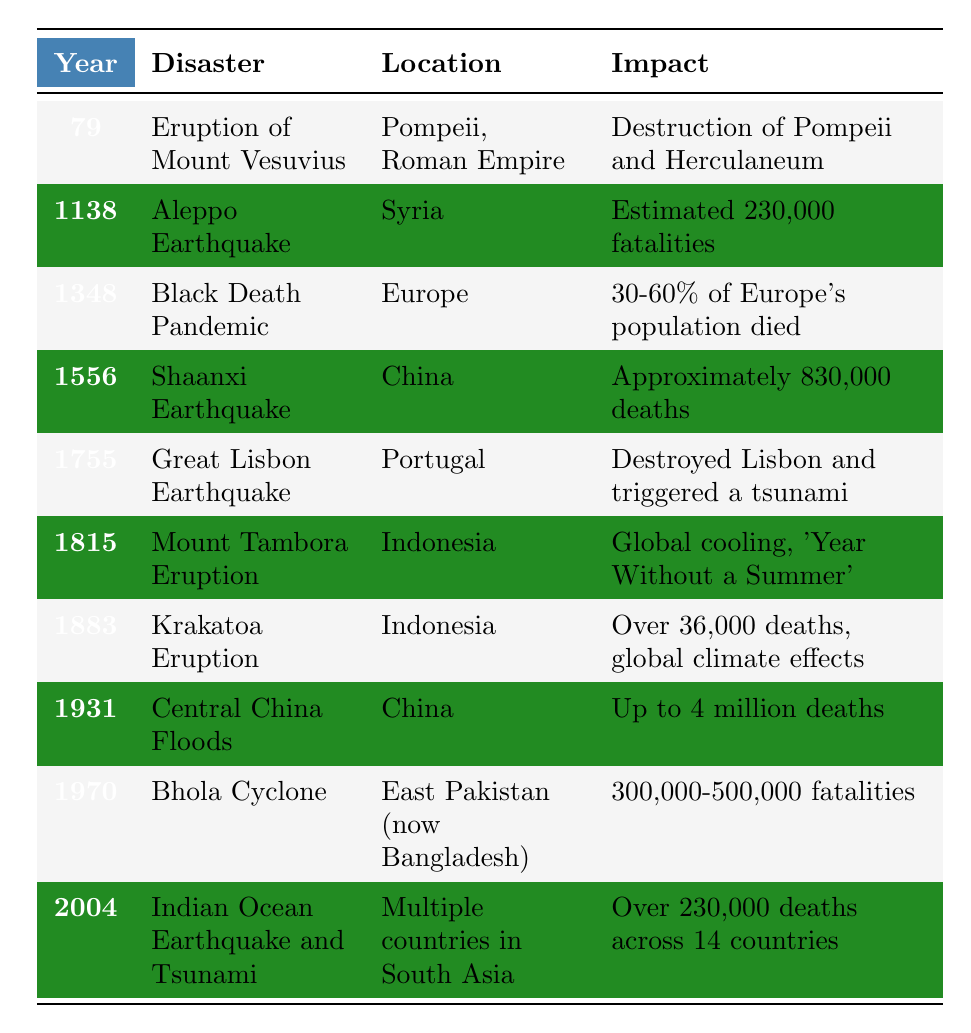What major disaster occurred in the year 1348? The table lists the "Black Death Pandemic" as the disaster that took place in 1348.
Answer: Black Death Pandemic Which disaster caused approximately 830,000 deaths? Referring to the table, the "Shaanxi Earthquake" in 1556 is noted for causing approximately 830,000 deaths.
Answer: Shaanxi Earthquake What is the estimated number of fatalities from the Aleppo Earthquake? According to the table, the Aleppo Earthquake in 1138 had an estimated 230,000 fatalities.
Answer: 230,000 fatalities In which country did the Great Lisbon Earthquake occur? The table indicates that the Great Lisbon Earthquake occurred in Portugal.
Answer: Portugal What is the impact of the Mount Tambora Eruption in 1815? The table states that the Mount Tambora Eruption led to global cooling, resulting in what was known as the 'Year Without a Summer.'
Answer: Global cooling, 'Year Without a Summer' How many disasters listed occurred in the 1800s? Looking at the table, there are three listed disasters in the 1800s: Mount Tambora Eruption (1815), Krakatoa Eruption (1883), and the Great Lisbon Earthquake (1755). These are counted to give a total of three.
Answer: 3 Was there a natural disaster that resulted in up to 4 million deaths? The table indicates that the Central China Floods in 1931 had an impact of up to 4 million deaths, confirming the fact.
Answer: Yes Which disaster occurred closest to the year 2000? Reviewing the table, the disaster occurring closest to the year 2000 is the Indian Ocean Earthquake and Tsunami, which happened in 2004.
Answer: Indian Ocean Earthquake and Tsunami Which two disasters occurred in Indonesia? The table references two disasters that occurred in Indonesia: the Mount Tambora Eruption in 1815 and the Krakatoa Eruption in 1883.
Answer: Mount Tambora Eruption and Krakatoa Eruption What is the time gap between the Shaanxi Earthquake and the Black Death Pandemic? To find the time gap, subtract the year of the Black Death Pandemic (1348) from the year of the Shaanxi Earthquake (1556) resulting in 1556 - 1348 = 208 years difference.
Answer: 208 years 